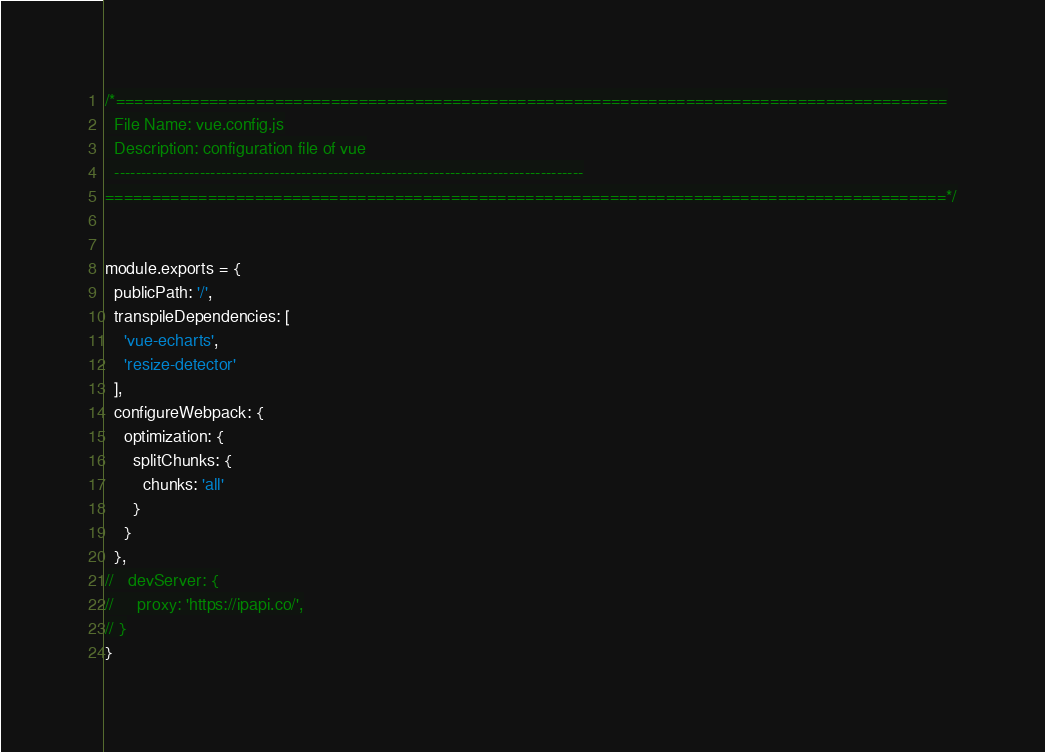<code> <loc_0><loc_0><loc_500><loc_500><_JavaScript_>/*=========================================================================================
  File Name: vue.config.js
  Description: configuration file of vue
  ----------------------------------------------------------------------------------------
==========================================================================================*/


module.exports = {
  publicPath: '/',
  transpileDependencies: [
    'vue-echarts',
    'resize-detector'
  ],
  configureWebpack: {
    optimization: {
      splitChunks: {
        chunks: 'all'
      }
    }
  },
//   devServer: {
//     proxy: 'https://ipapi.co/',
// }
}

</code> 